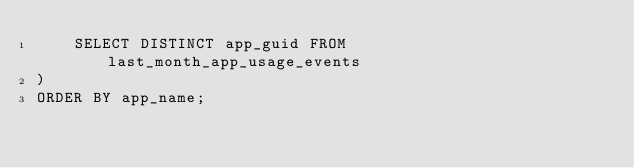<code> <loc_0><loc_0><loc_500><loc_500><_SQL_>    SELECT DISTINCT app_guid FROM last_month_app_usage_events
)
ORDER BY app_name;

</code> 